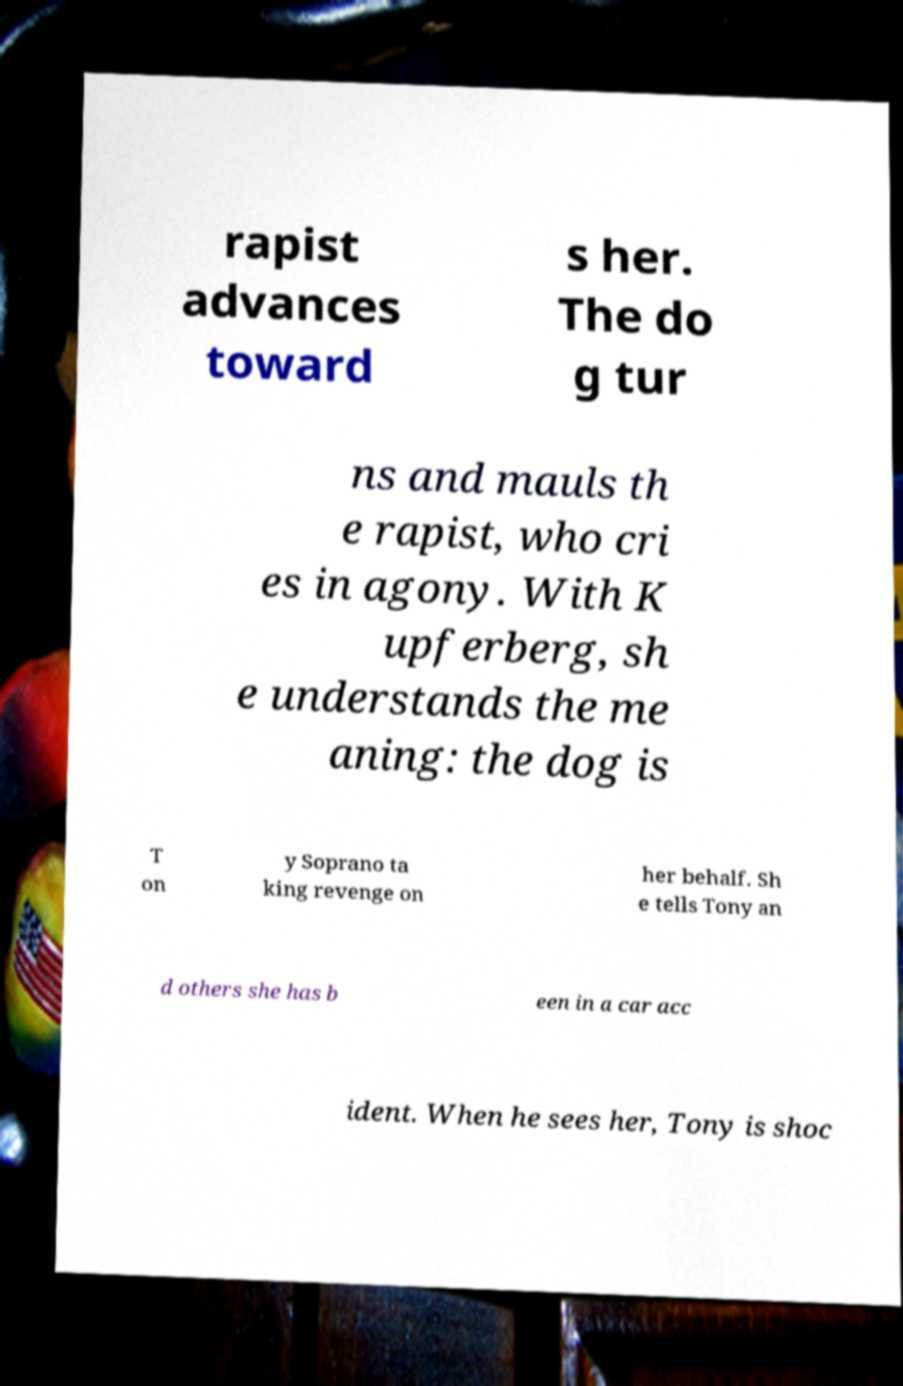Can you read and provide the text displayed in the image?This photo seems to have some interesting text. Can you extract and type it out for me? rapist advances toward s her. The do g tur ns and mauls th e rapist, who cri es in agony. With K upferberg, sh e understands the me aning: the dog is T on y Soprano ta king revenge on her behalf. Sh e tells Tony an d others she has b een in a car acc ident. When he sees her, Tony is shoc 